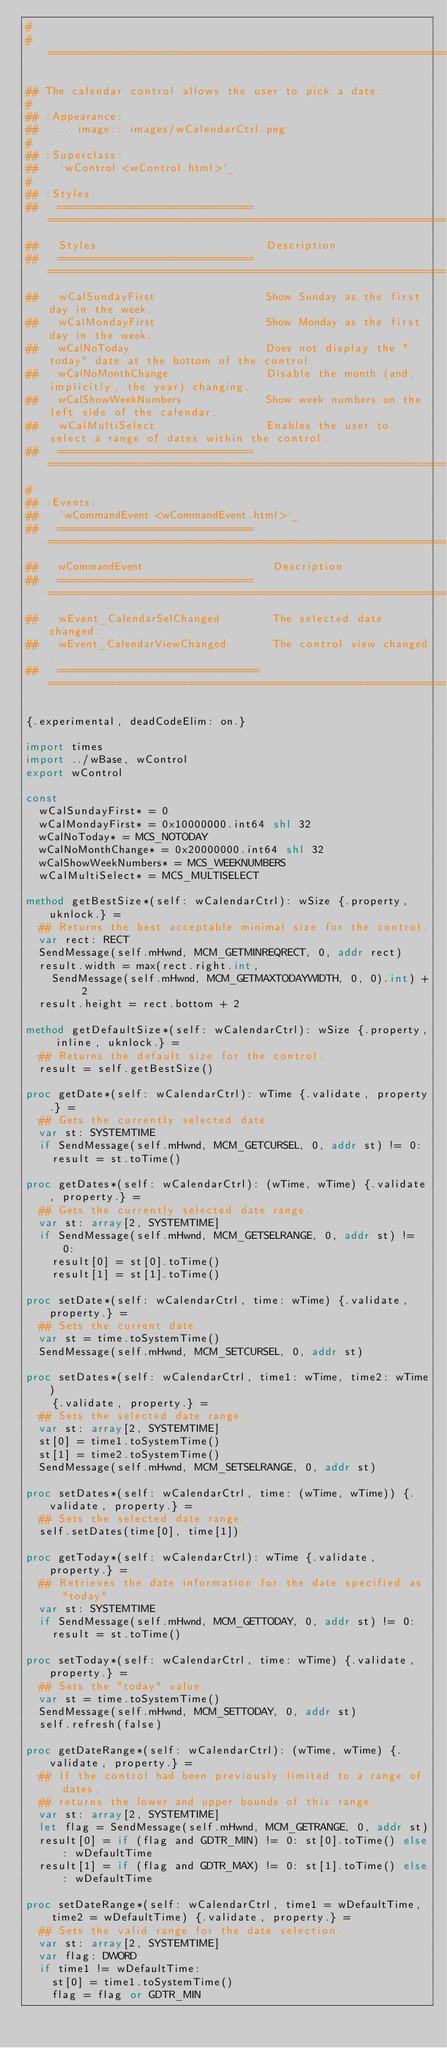Convert code to text. <code><loc_0><loc_0><loc_500><loc_500><_Nim_>#
#====================================================================

## The calendar control allows the user to pick a date.
#
## :Appearance:
##   .. image:: images/wCalendarCtrl.png
#
## :Superclass:
##   `wControl <wControl.html>`_
#
## :Styles:
##   ==============================  =============================================================
##   Styles                          Description
##   ==============================  =============================================================
##   wCalSundayFirst                 Show Sunday as the first day in the week.
##   wCalMondayFirst                 Show Monday as the first day in the week.
##   wCalNoToday                     Does not display the "today" date at the bottom of the control.
##   wCalNoMonthChange               Disable the month (and, implicitly, the year) changing.
##   wCalShowWeekNumbers             Show week numbers on the left side of the calendar.
##   wCalMultiSelect                 Enables the user to select a range of dates within the control.
##   ==============================  =============================================================
#
## :Events:
##   `wCommandEvent <wCommandEvent.html>`_
##   ==============================   =============================================================
##   wCommandEvent                    Description
##   ==============================   =============================================================
##   wEvent_CalendarSelChanged        The selected date changed.
##   wEvent_CalendarViewChanged       The control view changed.
##   ===============================  =============================================================

{.experimental, deadCodeElim: on.}

import times
import ../wBase, wControl
export wControl

const
  wCalSundayFirst* = 0
  wCalMondayFirst* = 0x10000000.int64 shl 32
  wCalNoToday* = MCS_NOTODAY
  wCalNoMonthChange* = 0x20000000.int64 shl 32
  wCalShowWeekNumbers* = MCS_WEEKNUMBERS
  wCalMultiSelect* = MCS_MULTISELECT

method getBestSize*(self: wCalendarCtrl): wSize {.property, uknlock.} =
  ## Returns the best acceptable minimal size for the control.
  var rect: RECT
  SendMessage(self.mHwnd, MCM_GETMINREQRECT, 0, addr rect)
  result.width = max(rect.right.int,
    SendMessage(self.mHwnd, MCM_GETMAXTODAYWIDTH, 0, 0).int) + 2
  result.height = rect.bottom + 2

method getDefaultSize*(self: wCalendarCtrl): wSize {.property, inline, uknlock.} =
  ## Returns the default size for the control.
  result = self.getBestSize()

proc getDate*(self: wCalendarCtrl): wTime {.validate, property.} =
  ## Gets the currently selected date.
  var st: SYSTEMTIME
  if SendMessage(self.mHwnd, MCM_GETCURSEL, 0, addr st) != 0:
    result = st.toTime()

proc getDates*(self: wCalendarCtrl): (wTime, wTime) {.validate, property.} =
  ## Gets the currently selected date range.
  var st: array[2, SYSTEMTIME]
  if SendMessage(self.mHwnd, MCM_GETSELRANGE, 0, addr st) != 0:
    result[0] = st[0].toTime()
    result[1] = st[1].toTime()

proc setDate*(self: wCalendarCtrl, time: wTime) {.validate, property.} =
  ## Sets the current date.
  var st = time.toSystemTime()
  SendMessage(self.mHwnd, MCM_SETCURSEL, 0, addr st)

proc setDates*(self: wCalendarCtrl, time1: wTime, time2: wTime)
    {.validate, property.} =
  ## Sets the selected date range.
  var st: array[2, SYSTEMTIME]
  st[0] = time1.toSystemTime()
  st[1] = time2.toSystemTime()
  SendMessage(self.mHwnd, MCM_SETSELRANGE, 0, addr st)

proc setDates*(self: wCalendarCtrl, time: (wTime, wTime)) {.validate, property.} =
  ## Sets the selected date range.
  self.setDates(time[0], time[1])

proc getToday*(self: wCalendarCtrl): wTime {.validate, property.} =
  ## Retrieves the date information for the date specified as "today"
  var st: SYSTEMTIME
  if SendMessage(self.mHwnd, MCM_GETTODAY, 0, addr st) != 0:
    result = st.toTime()

proc setToday*(self: wCalendarCtrl, time: wTime) {.validate, property.} =
  ## Sets the "today" value.
  var st = time.toSystemTime()
  SendMessage(self.mHwnd, MCM_SETTODAY, 0, addr st)
  self.refresh(false)

proc getDateRange*(self: wCalendarCtrl): (wTime, wTime) {.validate, property.} =
  ## If the control had been previously limited to a range of dates,
  ## returns the lower and upper bounds of this range.
  var st: array[2, SYSTEMTIME]
  let flag = SendMessage(self.mHwnd, MCM_GETRANGE, 0, addr st)
  result[0] = if (flag and GDTR_MIN) != 0: st[0].toTime() else: wDefaultTime
  result[1] = if (flag and GDTR_MAX) != 0: st[1].toTime() else: wDefaultTime

proc setDateRange*(self: wCalendarCtrl, time1 = wDefaultTime,
    time2 = wDefaultTime) {.validate, property.} =
  ## Sets the valid range for the date selection.
  var st: array[2, SYSTEMTIME]
  var flag: DWORD
  if time1 != wDefaultTime:
    st[0] = time1.toSystemTime()
    flag = flag or GDTR_MIN
</code> 